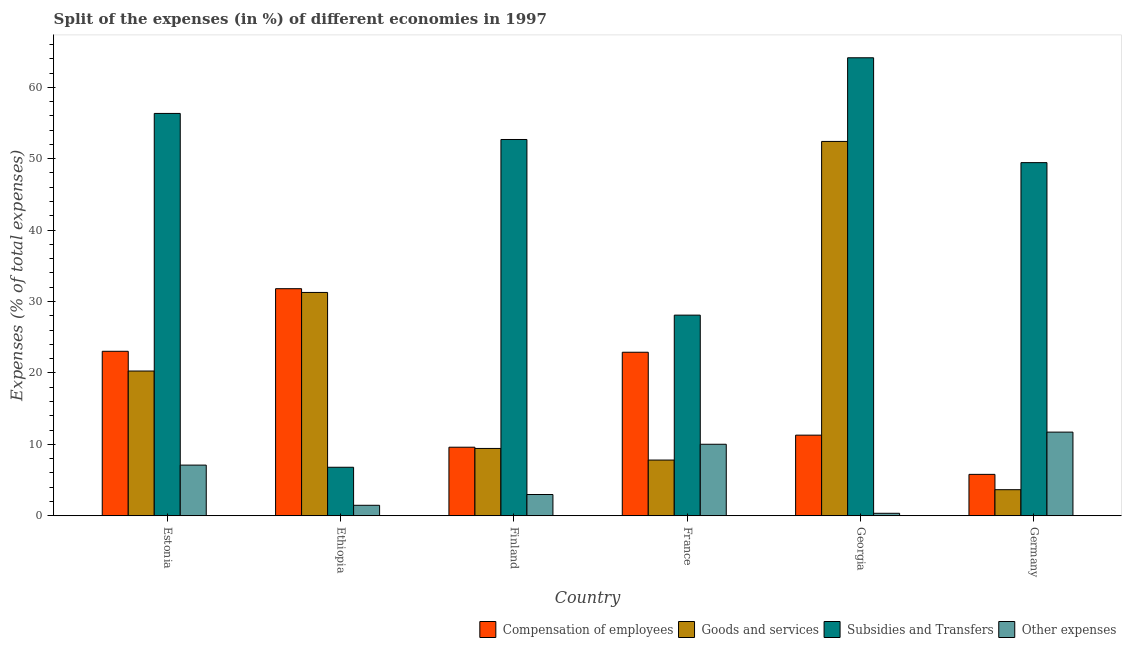How many different coloured bars are there?
Ensure brevity in your answer.  4. How many bars are there on the 2nd tick from the left?
Keep it short and to the point. 4. What is the label of the 5th group of bars from the left?
Your response must be concise. Georgia. In how many cases, is the number of bars for a given country not equal to the number of legend labels?
Ensure brevity in your answer.  0. What is the percentage of amount spent on goods and services in Germany?
Make the answer very short. 3.65. Across all countries, what is the maximum percentage of amount spent on compensation of employees?
Keep it short and to the point. 31.8. Across all countries, what is the minimum percentage of amount spent on compensation of employees?
Give a very brief answer. 5.8. In which country was the percentage of amount spent on other expenses minimum?
Your answer should be very brief. Georgia. What is the total percentage of amount spent on subsidies in the graph?
Your answer should be compact. 257.51. What is the difference between the percentage of amount spent on goods and services in Finland and that in Germany?
Give a very brief answer. 5.78. What is the difference between the percentage of amount spent on subsidies in Estonia and the percentage of amount spent on other expenses in Germany?
Provide a succinct answer. 44.62. What is the average percentage of amount spent on other expenses per country?
Offer a terse response. 5.61. What is the difference between the percentage of amount spent on subsidies and percentage of amount spent on goods and services in Georgia?
Provide a succinct answer. 11.71. What is the ratio of the percentage of amount spent on goods and services in Estonia to that in Germany?
Keep it short and to the point. 5.55. Is the difference between the percentage of amount spent on goods and services in France and Georgia greater than the difference between the percentage of amount spent on subsidies in France and Georgia?
Provide a short and direct response. No. What is the difference between the highest and the second highest percentage of amount spent on compensation of employees?
Provide a short and direct response. 8.76. What is the difference between the highest and the lowest percentage of amount spent on other expenses?
Give a very brief answer. 11.37. In how many countries, is the percentage of amount spent on other expenses greater than the average percentage of amount spent on other expenses taken over all countries?
Ensure brevity in your answer.  3. Is it the case that in every country, the sum of the percentage of amount spent on compensation of employees and percentage of amount spent on goods and services is greater than the sum of percentage of amount spent on other expenses and percentage of amount spent on subsidies?
Your answer should be very brief. No. What does the 1st bar from the left in Finland represents?
Provide a succinct answer. Compensation of employees. What does the 3rd bar from the right in Finland represents?
Keep it short and to the point. Goods and services. Is it the case that in every country, the sum of the percentage of amount spent on compensation of employees and percentage of amount spent on goods and services is greater than the percentage of amount spent on subsidies?
Make the answer very short. No. How many bars are there?
Provide a succinct answer. 24. What is the difference between two consecutive major ticks on the Y-axis?
Provide a succinct answer. 10. Are the values on the major ticks of Y-axis written in scientific E-notation?
Provide a short and direct response. No. Does the graph contain any zero values?
Your answer should be compact. No. Does the graph contain grids?
Make the answer very short. No. What is the title of the graph?
Your response must be concise. Split of the expenses (in %) of different economies in 1997. What is the label or title of the Y-axis?
Your answer should be very brief. Expenses (% of total expenses). What is the Expenses (% of total expenses) in Compensation of employees in Estonia?
Offer a terse response. 23.03. What is the Expenses (% of total expenses) of Goods and services in Estonia?
Ensure brevity in your answer.  20.27. What is the Expenses (% of total expenses) in Subsidies and Transfers in Estonia?
Your answer should be compact. 56.34. What is the Expenses (% of total expenses) of Other expenses in Estonia?
Your response must be concise. 7.1. What is the Expenses (% of total expenses) of Compensation of employees in Ethiopia?
Ensure brevity in your answer.  31.8. What is the Expenses (% of total expenses) of Goods and services in Ethiopia?
Offer a very short reply. 31.27. What is the Expenses (% of total expenses) in Subsidies and Transfers in Ethiopia?
Your response must be concise. 6.8. What is the Expenses (% of total expenses) in Other expenses in Ethiopia?
Your answer should be very brief. 1.47. What is the Expenses (% of total expenses) of Compensation of employees in Finland?
Your answer should be very brief. 9.6. What is the Expenses (% of total expenses) in Goods and services in Finland?
Your answer should be very brief. 9.43. What is the Expenses (% of total expenses) of Subsidies and Transfers in Finland?
Your answer should be compact. 52.69. What is the Expenses (% of total expenses) in Other expenses in Finland?
Offer a very short reply. 2.98. What is the Expenses (% of total expenses) in Compensation of employees in France?
Your answer should be compact. 22.9. What is the Expenses (% of total expenses) in Goods and services in France?
Your response must be concise. 7.81. What is the Expenses (% of total expenses) of Subsidies and Transfers in France?
Ensure brevity in your answer.  28.1. What is the Expenses (% of total expenses) in Other expenses in France?
Give a very brief answer. 10.02. What is the Expenses (% of total expenses) in Compensation of employees in Georgia?
Provide a succinct answer. 11.29. What is the Expenses (% of total expenses) in Goods and services in Georgia?
Your answer should be compact. 52.42. What is the Expenses (% of total expenses) of Subsidies and Transfers in Georgia?
Offer a terse response. 64.13. What is the Expenses (% of total expenses) of Other expenses in Georgia?
Make the answer very short. 0.35. What is the Expenses (% of total expenses) of Compensation of employees in Germany?
Provide a succinct answer. 5.8. What is the Expenses (% of total expenses) in Goods and services in Germany?
Give a very brief answer. 3.65. What is the Expenses (% of total expenses) of Subsidies and Transfers in Germany?
Your response must be concise. 49.45. What is the Expenses (% of total expenses) in Other expenses in Germany?
Your answer should be very brief. 11.72. Across all countries, what is the maximum Expenses (% of total expenses) in Compensation of employees?
Provide a short and direct response. 31.8. Across all countries, what is the maximum Expenses (% of total expenses) of Goods and services?
Give a very brief answer. 52.42. Across all countries, what is the maximum Expenses (% of total expenses) of Subsidies and Transfers?
Ensure brevity in your answer.  64.13. Across all countries, what is the maximum Expenses (% of total expenses) of Other expenses?
Offer a very short reply. 11.72. Across all countries, what is the minimum Expenses (% of total expenses) of Compensation of employees?
Your answer should be compact. 5.8. Across all countries, what is the minimum Expenses (% of total expenses) of Goods and services?
Provide a succinct answer. 3.65. Across all countries, what is the minimum Expenses (% of total expenses) in Subsidies and Transfers?
Make the answer very short. 6.8. Across all countries, what is the minimum Expenses (% of total expenses) in Other expenses?
Your answer should be compact. 0.35. What is the total Expenses (% of total expenses) of Compensation of employees in the graph?
Provide a succinct answer. 104.43. What is the total Expenses (% of total expenses) of Goods and services in the graph?
Keep it short and to the point. 124.86. What is the total Expenses (% of total expenses) in Subsidies and Transfers in the graph?
Your response must be concise. 257.51. What is the total Expenses (% of total expenses) of Other expenses in the graph?
Your answer should be very brief. 33.63. What is the difference between the Expenses (% of total expenses) in Compensation of employees in Estonia and that in Ethiopia?
Make the answer very short. -8.76. What is the difference between the Expenses (% of total expenses) in Goods and services in Estonia and that in Ethiopia?
Provide a short and direct response. -11. What is the difference between the Expenses (% of total expenses) of Subsidies and Transfers in Estonia and that in Ethiopia?
Keep it short and to the point. 49.54. What is the difference between the Expenses (% of total expenses) in Other expenses in Estonia and that in Ethiopia?
Your response must be concise. 5.63. What is the difference between the Expenses (% of total expenses) in Compensation of employees in Estonia and that in Finland?
Give a very brief answer. 13.43. What is the difference between the Expenses (% of total expenses) of Goods and services in Estonia and that in Finland?
Provide a succinct answer. 10.84. What is the difference between the Expenses (% of total expenses) in Subsidies and Transfers in Estonia and that in Finland?
Offer a very short reply. 3.65. What is the difference between the Expenses (% of total expenses) of Other expenses in Estonia and that in Finland?
Your response must be concise. 4.12. What is the difference between the Expenses (% of total expenses) of Compensation of employees in Estonia and that in France?
Your answer should be very brief. 0.13. What is the difference between the Expenses (% of total expenses) of Goods and services in Estonia and that in France?
Provide a short and direct response. 12.47. What is the difference between the Expenses (% of total expenses) in Subsidies and Transfers in Estonia and that in France?
Your answer should be very brief. 28.24. What is the difference between the Expenses (% of total expenses) of Other expenses in Estonia and that in France?
Give a very brief answer. -2.92. What is the difference between the Expenses (% of total expenses) of Compensation of employees in Estonia and that in Georgia?
Make the answer very short. 11.74. What is the difference between the Expenses (% of total expenses) of Goods and services in Estonia and that in Georgia?
Keep it short and to the point. -32.15. What is the difference between the Expenses (% of total expenses) in Subsidies and Transfers in Estonia and that in Georgia?
Offer a very short reply. -7.79. What is the difference between the Expenses (% of total expenses) of Other expenses in Estonia and that in Georgia?
Make the answer very short. 6.75. What is the difference between the Expenses (% of total expenses) in Compensation of employees in Estonia and that in Germany?
Offer a terse response. 17.23. What is the difference between the Expenses (% of total expenses) of Goods and services in Estonia and that in Germany?
Provide a succinct answer. 16.62. What is the difference between the Expenses (% of total expenses) in Subsidies and Transfers in Estonia and that in Germany?
Your response must be concise. 6.89. What is the difference between the Expenses (% of total expenses) of Other expenses in Estonia and that in Germany?
Offer a very short reply. -4.62. What is the difference between the Expenses (% of total expenses) of Compensation of employees in Ethiopia and that in Finland?
Your answer should be very brief. 22.2. What is the difference between the Expenses (% of total expenses) of Goods and services in Ethiopia and that in Finland?
Your response must be concise. 21.84. What is the difference between the Expenses (% of total expenses) of Subsidies and Transfers in Ethiopia and that in Finland?
Offer a terse response. -45.9. What is the difference between the Expenses (% of total expenses) in Other expenses in Ethiopia and that in Finland?
Provide a short and direct response. -1.51. What is the difference between the Expenses (% of total expenses) of Compensation of employees in Ethiopia and that in France?
Provide a short and direct response. 8.9. What is the difference between the Expenses (% of total expenses) of Goods and services in Ethiopia and that in France?
Your answer should be compact. 23.47. What is the difference between the Expenses (% of total expenses) in Subsidies and Transfers in Ethiopia and that in France?
Offer a very short reply. -21.3. What is the difference between the Expenses (% of total expenses) of Other expenses in Ethiopia and that in France?
Ensure brevity in your answer.  -8.54. What is the difference between the Expenses (% of total expenses) of Compensation of employees in Ethiopia and that in Georgia?
Keep it short and to the point. 20.51. What is the difference between the Expenses (% of total expenses) in Goods and services in Ethiopia and that in Georgia?
Ensure brevity in your answer.  -21.14. What is the difference between the Expenses (% of total expenses) of Subsidies and Transfers in Ethiopia and that in Georgia?
Give a very brief answer. -57.34. What is the difference between the Expenses (% of total expenses) in Other expenses in Ethiopia and that in Georgia?
Offer a terse response. 1.12. What is the difference between the Expenses (% of total expenses) in Compensation of employees in Ethiopia and that in Germany?
Your response must be concise. 26. What is the difference between the Expenses (% of total expenses) of Goods and services in Ethiopia and that in Germany?
Give a very brief answer. 27.62. What is the difference between the Expenses (% of total expenses) in Subsidies and Transfers in Ethiopia and that in Germany?
Your answer should be very brief. -42.66. What is the difference between the Expenses (% of total expenses) in Other expenses in Ethiopia and that in Germany?
Your answer should be very brief. -10.24. What is the difference between the Expenses (% of total expenses) in Compensation of employees in Finland and that in France?
Your answer should be compact. -13.3. What is the difference between the Expenses (% of total expenses) of Goods and services in Finland and that in France?
Give a very brief answer. 1.62. What is the difference between the Expenses (% of total expenses) of Subsidies and Transfers in Finland and that in France?
Ensure brevity in your answer.  24.59. What is the difference between the Expenses (% of total expenses) of Other expenses in Finland and that in France?
Offer a very short reply. -7.04. What is the difference between the Expenses (% of total expenses) in Compensation of employees in Finland and that in Georgia?
Your answer should be very brief. -1.69. What is the difference between the Expenses (% of total expenses) in Goods and services in Finland and that in Georgia?
Offer a terse response. -42.99. What is the difference between the Expenses (% of total expenses) of Subsidies and Transfers in Finland and that in Georgia?
Keep it short and to the point. -11.44. What is the difference between the Expenses (% of total expenses) of Other expenses in Finland and that in Georgia?
Make the answer very short. 2.63. What is the difference between the Expenses (% of total expenses) of Compensation of employees in Finland and that in Germany?
Give a very brief answer. 3.8. What is the difference between the Expenses (% of total expenses) of Goods and services in Finland and that in Germany?
Your answer should be compact. 5.78. What is the difference between the Expenses (% of total expenses) of Subsidies and Transfers in Finland and that in Germany?
Make the answer very short. 3.24. What is the difference between the Expenses (% of total expenses) in Other expenses in Finland and that in Germany?
Your response must be concise. -8.74. What is the difference between the Expenses (% of total expenses) of Compensation of employees in France and that in Georgia?
Provide a succinct answer. 11.61. What is the difference between the Expenses (% of total expenses) in Goods and services in France and that in Georgia?
Make the answer very short. -44.61. What is the difference between the Expenses (% of total expenses) of Subsidies and Transfers in France and that in Georgia?
Your answer should be very brief. -36.04. What is the difference between the Expenses (% of total expenses) in Other expenses in France and that in Georgia?
Offer a terse response. 9.67. What is the difference between the Expenses (% of total expenses) in Compensation of employees in France and that in Germany?
Keep it short and to the point. 17.1. What is the difference between the Expenses (% of total expenses) of Goods and services in France and that in Germany?
Provide a succinct answer. 4.15. What is the difference between the Expenses (% of total expenses) in Subsidies and Transfers in France and that in Germany?
Provide a succinct answer. -21.35. What is the difference between the Expenses (% of total expenses) of Other expenses in France and that in Germany?
Make the answer very short. -1.7. What is the difference between the Expenses (% of total expenses) in Compensation of employees in Georgia and that in Germany?
Ensure brevity in your answer.  5.49. What is the difference between the Expenses (% of total expenses) of Goods and services in Georgia and that in Germany?
Your response must be concise. 48.77. What is the difference between the Expenses (% of total expenses) of Subsidies and Transfers in Georgia and that in Germany?
Provide a short and direct response. 14.68. What is the difference between the Expenses (% of total expenses) of Other expenses in Georgia and that in Germany?
Make the answer very short. -11.37. What is the difference between the Expenses (% of total expenses) in Compensation of employees in Estonia and the Expenses (% of total expenses) in Goods and services in Ethiopia?
Offer a terse response. -8.24. What is the difference between the Expenses (% of total expenses) of Compensation of employees in Estonia and the Expenses (% of total expenses) of Subsidies and Transfers in Ethiopia?
Your answer should be very brief. 16.24. What is the difference between the Expenses (% of total expenses) of Compensation of employees in Estonia and the Expenses (% of total expenses) of Other expenses in Ethiopia?
Offer a very short reply. 21.56. What is the difference between the Expenses (% of total expenses) of Goods and services in Estonia and the Expenses (% of total expenses) of Subsidies and Transfers in Ethiopia?
Your answer should be very brief. 13.48. What is the difference between the Expenses (% of total expenses) in Goods and services in Estonia and the Expenses (% of total expenses) in Other expenses in Ethiopia?
Keep it short and to the point. 18.8. What is the difference between the Expenses (% of total expenses) in Subsidies and Transfers in Estonia and the Expenses (% of total expenses) in Other expenses in Ethiopia?
Offer a very short reply. 54.87. What is the difference between the Expenses (% of total expenses) in Compensation of employees in Estonia and the Expenses (% of total expenses) in Goods and services in Finland?
Ensure brevity in your answer.  13.6. What is the difference between the Expenses (% of total expenses) in Compensation of employees in Estonia and the Expenses (% of total expenses) in Subsidies and Transfers in Finland?
Keep it short and to the point. -29.66. What is the difference between the Expenses (% of total expenses) of Compensation of employees in Estonia and the Expenses (% of total expenses) of Other expenses in Finland?
Give a very brief answer. 20.05. What is the difference between the Expenses (% of total expenses) in Goods and services in Estonia and the Expenses (% of total expenses) in Subsidies and Transfers in Finland?
Provide a succinct answer. -32.42. What is the difference between the Expenses (% of total expenses) of Goods and services in Estonia and the Expenses (% of total expenses) of Other expenses in Finland?
Offer a terse response. 17.29. What is the difference between the Expenses (% of total expenses) of Subsidies and Transfers in Estonia and the Expenses (% of total expenses) of Other expenses in Finland?
Offer a very short reply. 53.36. What is the difference between the Expenses (% of total expenses) in Compensation of employees in Estonia and the Expenses (% of total expenses) in Goods and services in France?
Give a very brief answer. 15.23. What is the difference between the Expenses (% of total expenses) in Compensation of employees in Estonia and the Expenses (% of total expenses) in Subsidies and Transfers in France?
Ensure brevity in your answer.  -5.06. What is the difference between the Expenses (% of total expenses) in Compensation of employees in Estonia and the Expenses (% of total expenses) in Other expenses in France?
Offer a terse response. 13.02. What is the difference between the Expenses (% of total expenses) in Goods and services in Estonia and the Expenses (% of total expenses) in Subsidies and Transfers in France?
Make the answer very short. -7.83. What is the difference between the Expenses (% of total expenses) of Goods and services in Estonia and the Expenses (% of total expenses) of Other expenses in France?
Your response must be concise. 10.26. What is the difference between the Expenses (% of total expenses) of Subsidies and Transfers in Estonia and the Expenses (% of total expenses) of Other expenses in France?
Provide a succinct answer. 46.32. What is the difference between the Expenses (% of total expenses) in Compensation of employees in Estonia and the Expenses (% of total expenses) in Goods and services in Georgia?
Offer a terse response. -29.38. What is the difference between the Expenses (% of total expenses) in Compensation of employees in Estonia and the Expenses (% of total expenses) in Subsidies and Transfers in Georgia?
Your answer should be compact. -41.1. What is the difference between the Expenses (% of total expenses) of Compensation of employees in Estonia and the Expenses (% of total expenses) of Other expenses in Georgia?
Your answer should be very brief. 22.68. What is the difference between the Expenses (% of total expenses) in Goods and services in Estonia and the Expenses (% of total expenses) in Subsidies and Transfers in Georgia?
Offer a very short reply. -43.86. What is the difference between the Expenses (% of total expenses) in Goods and services in Estonia and the Expenses (% of total expenses) in Other expenses in Georgia?
Ensure brevity in your answer.  19.92. What is the difference between the Expenses (% of total expenses) in Subsidies and Transfers in Estonia and the Expenses (% of total expenses) in Other expenses in Georgia?
Give a very brief answer. 55.99. What is the difference between the Expenses (% of total expenses) of Compensation of employees in Estonia and the Expenses (% of total expenses) of Goods and services in Germany?
Your answer should be very brief. 19.38. What is the difference between the Expenses (% of total expenses) of Compensation of employees in Estonia and the Expenses (% of total expenses) of Subsidies and Transfers in Germany?
Your answer should be compact. -26.42. What is the difference between the Expenses (% of total expenses) in Compensation of employees in Estonia and the Expenses (% of total expenses) in Other expenses in Germany?
Offer a very short reply. 11.32. What is the difference between the Expenses (% of total expenses) in Goods and services in Estonia and the Expenses (% of total expenses) in Subsidies and Transfers in Germany?
Give a very brief answer. -29.18. What is the difference between the Expenses (% of total expenses) of Goods and services in Estonia and the Expenses (% of total expenses) of Other expenses in Germany?
Your response must be concise. 8.56. What is the difference between the Expenses (% of total expenses) of Subsidies and Transfers in Estonia and the Expenses (% of total expenses) of Other expenses in Germany?
Give a very brief answer. 44.62. What is the difference between the Expenses (% of total expenses) in Compensation of employees in Ethiopia and the Expenses (% of total expenses) in Goods and services in Finland?
Ensure brevity in your answer.  22.37. What is the difference between the Expenses (% of total expenses) in Compensation of employees in Ethiopia and the Expenses (% of total expenses) in Subsidies and Transfers in Finland?
Provide a succinct answer. -20.89. What is the difference between the Expenses (% of total expenses) of Compensation of employees in Ethiopia and the Expenses (% of total expenses) of Other expenses in Finland?
Keep it short and to the point. 28.82. What is the difference between the Expenses (% of total expenses) of Goods and services in Ethiopia and the Expenses (% of total expenses) of Subsidies and Transfers in Finland?
Make the answer very short. -21.42. What is the difference between the Expenses (% of total expenses) of Goods and services in Ethiopia and the Expenses (% of total expenses) of Other expenses in Finland?
Make the answer very short. 28.29. What is the difference between the Expenses (% of total expenses) in Subsidies and Transfers in Ethiopia and the Expenses (% of total expenses) in Other expenses in Finland?
Your response must be concise. 3.82. What is the difference between the Expenses (% of total expenses) in Compensation of employees in Ethiopia and the Expenses (% of total expenses) in Goods and services in France?
Provide a succinct answer. 23.99. What is the difference between the Expenses (% of total expenses) in Compensation of employees in Ethiopia and the Expenses (% of total expenses) in Subsidies and Transfers in France?
Give a very brief answer. 3.7. What is the difference between the Expenses (% of total expenses) of Compensation of employees in Ethiopia and the Expenses (% of total expenses) of Other expenses in France?
Make the answer very short. 21.78. What is the difference between the Expenses (% of total expenses) of Goods and services in Ethiopia and the Expenses (% of total expenses) of Subsidies and Transfers in France?
Provide a succinct answer. 3.18. What is the difference between the Expenses (% of total expenses) of Goods and services in Ethiopia and the Expenses (% of total expenses) of Other expenses in France?
Your answer should be compact. 21.26. What is the difference between the Expenses (% of total expenses) in Subsidies and Transfers in Ethiopia and the Expenses (% of total expenses) in Other expenses in France?
Your response must be concise. -3.22. What is the difference between the Expenses (% of total expenses) of Compensation of employees in Ethiopia and the Expenses (% of total expenses) of Goods and services in Georgia?
Your response must be concise. -20.62. What is the difference between the Expenses (% of total expenses) in Compensation of employees in Ethiopia and the Expenses (% of total expenses) in Subsidies and Transfers in Georgia?
Your answer should be very brief. -32.33. What is the difference between the Expenses (% of total expenses) of Compensation of employees in Ethiopia and the Expenses (% of total expenses) of Other expenses in Georgia?
Your answer should be compact. 31.45. What is the difference between the Expenses (% of total expenses) of Goods and services in Ethiopia and the Expenses (% of total expenses) of Subsidies and Transfers in Georgia?
Provide a short and direct response. -32.86. What is the difference between the Expenses (% of total expenses) of Goods and services in Ethiopia and the Expenses (% of total expenses) of Other expenses in Georgia?
Provide a short and direct response. 30.92. What is the difference between the Expenses (% of total expenses) in Subsidies and Transfers in Ethiopia and the Expenses (% of total expenses) in Other expenses in Georgia?
Ensure brevity in your answer.  6.45. What is the difference between the Expenses (% of total expenses) of Compensation of employees in Ethiopia and the Expenses (% of total expenses) of Goods and services in Germany?
Give a very brief answer. 28.14. What is the difference between the Expenses (% of total expenses) of Compensation of employees in Ethiopia and the Expenses (% of total expenses) of Subsidies and Transfers in Germany?
Offer a terse response. -17.65. What is the difference between the Expenses (% of total expenses) of Compensation of employees in Ethiopia and the Expenses (% of total expenses) of Other expenses in Germany?
Ensure brevity in your answer.  20.08. What is the difference between the Expenses (% of total expenses) in Goods and services in Ethiopia and the Expenses (% of total expenses) in Subsidies and Transfers in Germany?
Provide a short and direct response. -18.18. What is the difference between the Expenses (% of total expenses) of Goods and services in Ethiopia and the Expenses (% of total expenses) of Other expenses in Germany?
Make the answer very short. 19.56. What is the difference between the Expenses (% of total expenses) of Subsidies and Transfers in Ethiopia and the Expenses (% of total expenses) of Other expenses in Germany?
Provide a succinct answer. -4.92. What is the difference between the Expenses (% of total expenses) of Compensation of employees in Finland and the Expenses (% of total expenses) of Goods and services in France?
Your answer should be compact. 1.8. What is the difference between the Expenses (% of total expenses) in Compensation of employees in Finland and the Expenses (% of total expenses) in Subsidies and Transfers in France?
Make the answer very short. -18.49. What is the difference between the Expenses (% of total expenses) in Compensation of employees in Finland and the Expenses (% of total expenses) in Other expenses in France?
Keep it short and to the point. -0.41. What is the difference between the Expenses (% of total expenses) in Goods and services in Finland and the Expenses (% of total expenses) in Subsidies and Transfers in France?
Make the answer very short. -18.67. What is the difference between the Expenses (% of total expenses) of Goods and services in Finland and the Expenses (% of total expenses) of Other expenses in France?
Offer a terse response. -0.59. What is the difference between the Expenses (% of total expenses) of Subsidies and Transfers in Finland and the Expenses (% of total expenses) of Other expenses in France?
Provide a succinct answer. 42.68. What is the difference between the Expenses (% of total expenses) of Compensation of employees in Finland and the Expenses (% of total expenses) of Goods and services in Georgia?
Provide a succinct answer. -42.82. What is the difference between the Expenses (% of total expenses) in Compensation of employees in Finland and the Expenses (% of total expenses) in Subsidies and Transfers in Georgia?
Provide a short and direct response. -54.53. What is the difference between the Expenses (% of total expenses) in Compensation of employees in Finland and the Expenses (% of total expenses) in Other expenses in Georgia?
Provide a succinct answer. 9.25. What is the difference between the Expenses (% of total expenses) of Goods and services in Finland and the Expenses (% of total expenses) of Subsidies and Transfers in Georgia?
Your answer should be very brief. -54.7. What is the difference between the Expenses (% of total expenses) in Goods and services in Finland and the Expenses (% of total expenses) in Other expenses in Georgia?
Provide a short and direct response. 9.08. What is the difference between the Expenses (% of total expenses) in Subsidies and Transfers in Finland and the Expenses (% of total expenses) in Other expenses in Georgia?
Your answer should be compact. 52.34. What is the difference between the Expenses (% of total expenses) of Compensation of employees in Finland and the Expenses (% of total expenses) of Goods and services in Germany?
Make the answer very short. 5.95. What is the difference between the Expenses (% of total expenses) of Compensation of employees in Finland and the Expenses (% of total expenses) of Subsidies and Transfers in Germany?
Your answer should be compact. -39.85. What is the difference between the Expenses (% of total expenses) of Compensation of employees in Finland and the Expenses (% of total expenses) of Other expenses in Germany?
Your answer should be compact. -2.11. What is the difference between the Expenses (% of total expenses) in Goods and services in Finland and the Expenses (% of total expenses) in Subsidies and Transfers in Germany?
Make the answer very short. -40.02. What is the difference between the Expenses (% of total expenses) of Goods and services in Finland and the Expenses (% of total expenses) of Other expenses in Germany?
Offer a very short reply. -2.29. What is the difference between the Expenses (% of total expenses) of Subsidies and Transfers in Finland and the Expenses (% of total expenses) of Other expenses in Germany?
Your answer should be compact. 40.98. What is the difference between the Expenses (% of total expenses) in Compensation of employees in France and the Expenses (% of total expenses) in Goods and services in Georgia?
Your answer should be very brief. -29.52. What is the difference between the Expenses (% of total expenses) of Compensation of employees in France and the Expenses (% of total expenses) of Subsidies and Transfers in Georgia?
Ensure brevity in your answer.  -41.23. What is the difference between the Expenses (% of total expenses) of Compensation of employees in France and the Expenses (% of total expenses) of Other expenses in Georgia?
Offer a very short reply. 22.55. What is the difference between the Expenses (% of total expenses) of Goods and services in France and the Expenses (% of total expenses) of Subsidies and Transfers in Georgia?
Your response must be concise. -56.33. What is the difference between the Expenses (% of total expenses) in Goods and services in France and the Expenses (% of total expenses) in Other expenses in Georgia?
Offer a very short reply. 7.46. What is the difference between the Expenses (% of total expenses) of Subsidies and Transfers in France and the Expenses (% of total expenses) of Other expenses in Georgia?
Offer a very short reply. 27.75. What is the difference between the Expenses (% of total expenses) in Compensation of employees in France and the Expenses (% of total expenses) in Goods and services in Germany?
Your answer should be compact. 19.25. What is the difference between the Expenses (% of total expenses) in Compensation of employees in France and the Expenses (% of total expenses) in Subsidies and Transfers in Germany?
Your answer should be compact. -26.55. What is the difference between the Expenses (% of total expenses) in Compensation of employees in France and the Expenses (% of total expenses) in Other expenses in Germany?
Make the answer very short. 11.19. What is the difference between the Expenses (% of total expenses) in Goods and services in France and the Expenses (% of total expenses) in Subsidies and Transfers in Germany?
Your answer should be compact. -41.65. What is the difference between the Expenses (% of total expenses) of Goods and services in France and the Expenses (% of total expenses) of Other expenses in Germany?
Make the answer very short. -3.91. What is the difference between the Expenses (% of total expenses) of Subsidies and Transfers in France and the Expenses (% of total expenses) of Other expenses in Germany?
Make the answer very short. 16.38. What is the difference between the Expenses (% of total expenses) in Compensation of employees in Georgia and the Expenses (% of total expenses) in Goods and services in Germany?
Keep it short and to the point. 7.64. What is the difference between the Expenses (% of total expenses) in Compensation of employees in Georgia and the Expenses (% of total expenses) in Subsidies and Transfers in Germany?
Offer a terse response. -38.16. What is the difference between the Expenses (% of total expenses) in Compensation of employees in Georgia and the Expenses (% of total expenses) in Other expenses in Germany?
Make the answer very short. -0.42. What is the difference between the Expenses (% of total expenses) in Goods and services in Georgia and the Expenses (% of total expenses) in Subsidies and Transfers in Germany?
Offer a terse response. 2.97. What is the difference between the Expenses (% of total expenses) in Goods and services in Georgia and the Expenses (% of total expenses) in Other expenses in Germany?
Your response must be concise. 40.7. What is the difference between the Expenses (% of total expenses) in Subsidies and Transfers in Georgia and the Expenses (% of total expenses) in Other expenses in Germany?
Make the answer very short. 52.42. What is the average Expenses (% of total expenses) of Compensation of employees per country?
Offer a terse response. 17.41. What is the average Expenses (% of total expenses) in Goods and services per country?
Your answer should be compact. 20.81. What is the average Expenses (% of total expenses) of Subsidies and Transfers per country?
Your answer should be compact. 42.92. What is the average Expenses (% of total expenses) in Other expenses per country?
Provide a short and direct response. 5.61. What is the difference between the Expenses (% of total expenses) of Compensation of employees and Expenses (% of total expenses) of Goods and services in Estonia?
Make the answer very short. 2.76. What is the difference between the Expenses (% of total expenses) in Compensation of employees and Expenses (% of total expenses) in Subsidies and Transfers in Estonia?
Keep it short and to the point. -33.31. What is the difference between the Expenses (% of total expenses) in Compensation of employees and Expenses (% of total expenses) in Other expenses in Estonia?
Provide a succinct answer. 15.94. What is the difference between the Expenses (% of total expenses) of Goods and services and Expenses (% of total expenses) of Subsidies and Transfers in Estonia?
Offer a very short reply. -36.07. What is the difference between the Expenses (% of total expenses) of Goods and services and Expenses (% of total expenses) of Other expenses in Estonia?
Give a very brief answer. 13.17. What is the difference between the Expenses (% of total expenses) in Subsidies and Transfers and Expenses (% of total expenses) in Other expenses in Estonia?
Your response must be concise. 49.24. What is the difference between the Expenses (% of total expenses) of Compensation of employees and Expenses (% of total expenses) of Goods and services in Ethiopia?
Ensure brevity in your answer.  0.52. What is the difference between the Expenses (% of total expenses) of Compensation of employees and Expenses (% of total expenses) of Subsidies and Transfers in Ethiopia?
Offer a terse response. 25. What is the difference between the Expenses (% of total expenses) of Compensation of employees and Expenses (% of total expenses) of Other expenses in Ethiopia?
Keep it short and to the point. 30.33. What is the difference between the Expenses (% of total expenses) in Goods and services and Expenses (% of total expenses) in Subsidies and Transfers in Ethiopia?
Make the answer very short. 24.48. What is the difference between the Expenses (% of total expenses) of Goods and services and Expenses (% of total expenses) of Other expenses in Ethiopia?
Your answer should be very brief. 29.8. What is the difference between the Expenses (% of total expenses) in Subsidies and Transfers and Expenses (% of total expenses) in Other expenses in Ethiopia?
Provide a short and direct response. 5.33. What is the difference between the Expenses (% of total expenses) of Compensation of employees and Expenses (% of total expenses) of Goods and services in Finland?
Provide a short and direct response. 0.17. What is the difference between the Expenses (% of total expenses) in Compensation of employees and Expenses (% of total expenses) in Subsidies and Transfers in Finland?
Provide a short and direct response. -43.09. What is the difference between the Expenses (% of total expenses) in Compensation of employees and Expenses (% of total expenses) in Other expenses in Finland?
Make the answer very short. 6.62. What is the difference between the Expenses (% of total expenses) of Goods and services and Expenses (% of total expenses) of Subsidies and Transfers in Finland?
Provide a short and direct response. -43.26. What is the difference between the Expenses (% of total expenses) in Goods and services and Expenses (% of total expenses) in Other expenses in Finland?
Give a very brief answer. 6.45. What is the difference between the Expenses (% of total expenses) of Subsidies and Transfers and Expenses (% of total expenses) of Other expenses in Finland?
Your response must be concise. 49.71. What is the difference between the Expenses (% of total expenses) in Compensation of employees and Expenses (% of total expenses) in Goods and services in France?
Your answer should be compact. 15.1. What is the difference between the Expenses (% of total expenses) in Compensation of employees and Expenses (% of total expenses) in Subsidies and Transfers in France?
Your answer should be very brief. -5.2. What is the difference between the Expenses (% of total expenses) in Compensation of employees and Expenses (% of total expenses) in Other expenses in France?
Your answer should be very brief. 12.89. What is the difference between the Expenses (% of total expenses) in Goods and services and Expenses (% of total expenses) in Subsidies and Transfers in France?
Keep it short and to the point. -20.29. What is the difference between the Expenses (% of total expenses) in Goods and services and Expenses (% of total expenses) in Other expenses in France?
Your answer should be compact. -2.21. What is the difference between the Expenses (% of total expenses) in Subsidies and Transfers and Expenses (% of total expenses) in Other expenses in France?
Keep it short and to the point. 18.08. What is the difference between the Expenses (% of total expenses) of Compensation of employees and Expenses (% of total expenses) of Goods and services in Georgia?
Give a very brief answer. -41.13. What is the difference between the Expenses (% of total expenses) in Compensation of employees and Expenses (% of total expenses) in Subsidies and Transfers in Georgia?
Provide a succinct answer. -52.84. What is the difference between the Expenses (% of total expenses) in Compensation of employees and Expenses (% of total expenses) in Other expenses in Georgia?
Offer a terse response. 10.94. What is the difference between the Expenses (% of total expenses) of Goods and services and Expenses (% of total expenses) of Subsidies and Transfers in Georgia?
Keep it short and to the point. -11.71. What is the difference between the Expenses (% of total expenses) of Goods and services and Expenses (% of total expenses) of Other expenses in Georgia?
Make the answer very short. 52.07. What is the difference between the Expenses (% of total expenses) in Subsidies and Transfers and Expenses (% of total expenses) in Other expenses in Georgia?
Ensure brevity in your answer.  63.78. What is the difference between the Expenses (% of total expenses) of Compensation of employees and Expenses (% of total expenses) of Goods and services in Germany?
Your answer should be compact. 2.15. What is the difference between the Expenses (% of total expenses) of Compensation of employees and Expenses (% of total expenses) of Subsidies and Transfers in Germany?
Offer a terse response. -43.65. What is the difference between the Expenses (% of total expenses) of Compensation of employees and Expenses (% of total expenses) of Other expenses in Germany?
Ensure brevity in your answer.  -5.91. What is the difference between the Expenses (% of total expenses) in Goods and services and Expenses (% of total expenses) in Subsidies and Transfers in Germany?
Ensure brevity in your answer.  -45.8. What is the difference between the Expenses (% of total expenses) of Goods and services and Expenses (% of total expenses) of Other expenses in Germany?
Ensure brevity in your answer.  -8.06. What is the difference between the Expenses (% of total expenses) in Subsidies and Transfers and Expenses (% of total expenses) in Other expenses in Germany?
Your answer should be compact. 37.74. What is the ratio of the Expenses (% of total expenses) in Compensation of employees in Estonia to that in Ethiopia?
Keep it short and to the point. 0.72. What is the ratio of the Expenses (% of total expenses) of Goods and services in Estonia to that in Ethiopia?
Offer a very short reply. 0.65. What is the ratio of the Expenses (% of total expenses) in Subsidies and Transfers in Estonia to that in Ethiopia?
Provide a short and direct response. 8.29. What is the ratio of the Expenses (% of total expenses) of Other expenses in Estonia to that in Ethiopia?
Your answer should be very brief. 4.83. What is the ratio of the Expenses (% of total expenses) of Compensation of employees in Estonia to that in Finland?
Ensure brevity in your answer.  2.4. What is the ratio of the Expenses (% of total expenses) of Goods and services in Estonia to that in Finland?
Your answer should be compact. 2.15. What is the ratio of the Expenses (% of total expenses) of Subsidies and Transfers in Estonia to that in Finland?
Make the answer very short. 1.07. What is the ratio of the Expenses (% of total expenses) of Other expenses in Estonia to that in Finland?
Provide a short and direct response. 2.38. What is the ratio of the Expenses (% of total expenses) of Goods and services in Estonia to that in France?
Keep it short and to the point. 2.6. What is the ratio of the Expenses (% of total expenses) in Subsidies and Transfers in Estonia to that in France?
Provide a succinct answer. 2.01. What is the ratio of the Expenses (% of total expenses) of Other expenses in Estonia to that in France?
Provide a succinct answer. 0.71. What is the ratio of the Expenses (% of total expenses) of Compensation of employees in Estonia to that in Georgia?
Provide a short and direct response. 2.04. What is the ratio of the Expenses (% of total expenses) of Goods and services in Estonia to that in Georgia?
Your answer should be very brief. 0.39. What is the ratio of the Expenses (% of total expenses) of Subsidies and Transfers in Estonia to that in Georgia?
Offer a terse response. 0.88. What is the ratio of the Expenses (% of total expenses) in Other expenses in Estonia to that in Georgia?
Ensure brevity in your answer.  20.27. What is the ratio of the Expenses (% of total expenses) of Compensation of employees in Estonia to that in Germany?
Give a very brief answer. 3.97. What is the ratio of the Expenses (% of total expenses) in Goods and services in Estonia to that in Germany?
Offer a terse response. 5.55. What is the ratio of the Expenses (% of total expenses) of Subsidies and Transfers in Estonia to that in Germany?
Your answer should be compact. 1.14. What is the ratio of the Expenses (% of total expenses) of Other expenses in Estonia to that in Germany?
Your answer should be compact. 0.61. What is the ratio of the Expenses (% of total expenses) in Compensation of employees in Ethiopia to that in Finland?
Your answer should be compact. 3.31. What is the ratio of the Expenses (% of total expenses) of Goods and services in Ethiopia to that in Finland?
Make the answer very short. 3.32. What is the ratio of the Expenses (% of total expenses) of Subsidies and Transfers in Ethiopia to that in Finland?
Offer a very short reply. 0.13. What is the ratio of the Expenses (% of total expenses) of Other expenses in Ethiopia to that in Finland?
Provide a short and direct response. 0.49. What is the ratio of the Expenses (% of total expenses) of Compensation of employees in Ethiopia to that in France?
Your answer should be compact. 1.39. What is the ratio of the Expenses (% of total expenses) of Goods and services in Ethiopia to that in France?
Make the answer very short. 4.01. What is the ratio of the Expenses (% of total expenses) in Subsidies and Transfers in Ethiopia to that in France?
Make the answer very short. 0.24. What is the ratio of the Expenses (% of total expenses) of Other expenses in Ethiopia to that in France?
Offer a terse response. 0.15. What is the ratio of the Expenses (% of total expenses) in Compensation of employees in Ethiopia to that in Georgia?
Offer a terse response. 2.82. What is the ratio of the Expenses (% of total expenses) in Goods and services in Ethiopia to that in Georgia?
Your response must be concise. 0.6. What is the ratio of the Expenses (% of total expenses) in Subsidies and Transfers in Ethiopia to that in Georgia?
Your answer should be compact. 0.11. What is the ratio of the Expenses (% of total expenses) of Other expenses in Ethiopia to that in Georgia?
Offer a terse response. 4.2. What is the ratio of the Expenses (% of total expenses) in Compensation of employees in Ethiopia to that in Germany?
Provide a short and direct response. 5.48. What is the ratio of the Expenses (% of total expenses) in Goods and services in Ethiopia to that in Germany?
Provide a succinct answer. 8.56. What is the ratio of the Expenses (% of total expenses) of Subsidies and Transfers in Ethiopia to that in Germany?
Your answer should be very brief. 0.14. What is the ratio of the Expenses (% of total expenses) in Other expenses in Ethiopia to that in Germany?
Your answer should be very brief. 0.13. What is the ratio of the Expenses (% of total expenses) of Compensation of employees in Finland to that in France?
Make the answer very short. 0.42. What is the ratio of the Expenses (% of total expenses) of Goods and services in Finland to that in France?
Your answer should be very brief. 1.21. What is the ratio of the Expenses (% of total expenses) in Subsidies and Transfers in Finland to that in France?
Provide a short and direct response. 1.88. What is the ratio of the Expenses (% of total expenses) of Other expenses in Finland to that in France?
Provide a short and direct response. 0.3. What is the ratio of the Expenses (% of total expenses) in Compensation of employees in Finland to that in Georgia?
Make the answer very short. 0.85. What is the ratio of the Expenses (% of total expenses) of Goods and services in Finland to that in Georgia?
Your answer should be compact. 0.18. What is the ratio of the Expenses (% of total expenses) of Subsidies and Transfers in Finland to that in Georgia?
Your response must be concise. 0.82. What is the ratio of the Expenses (% of total expenses) of Other expenses in Finland to that in Georgia?
Offer a terse response. 8.51. What is the ratio of the Expenses (% of total expenses) in Compensation of employees in Finland to that in Germany?
Provide a short and direct response. 1.66. What is the ratio of the Expenses (% of total expenses) of Goods and services in Finland to that in Germany?
Offer a very short reply. 2.58. What is the ratio of the Expenses (% of total expenses) of Subsidies and Transfers in Finland to that in Germany?
Offer a very short reply. 1.07. What is the ratio of the Expenses (% of total expenses) in Other expenses in Finland to that in Germany?
Keep it short and to the point. 0.25. What is the ratio of the Expenses (% of total expenses) of Compensation of employees in France to that in Georgia?
Your answer should be compact. 2.03. What is the ratio of the Expenses (% of total expenses) of Goods and services in France to that in Georgia?
Your answer should be very brief. 0.15. What is the ratio of the Expenses (% of total expenses) in Subsidies and Transfers in France to that in Georgia?
Make the answer very short. 0.44. What is the ratio of the Expenses (% of total expenses) of Other expenses in France to that in Georgia?
Make the answer very short. 28.6. What is the ratio of the Expenses (% of total expenses) of Compensation of employees in France to that in Germany?
Offer a terse response. 3.95. What is the ratio of the Expenses (% of total expenses) of Goods and services in France to that in Germany?
Provide a short and direct response. 2.14. What is the ratio of the Expenses (% of total expenses) in Subsidies and Transfers in France to that in Germany?
Provide a short and direct response. 0.57. What is the ratio of the Expenses (% of total expenses) in Other expenses in France to that in Germany?
Offer a terse response. 0.85. What is the ratio of the Expenses (% of total expenses) in Compensation of employees in Georgia to that in Germany?
Your response must be concise. 1.95. What is the ratio of the Expenses (% of total expenses) in Goods and services in Georgia to that in Germany?
Offer a very short reply. 14.34. What is the ratio of the Expenses (% of total expenses) in Subsidies and Transfers in Georgia to that in Germany?
Give a very brief answer. 1.3. What is the ratio of the Expenses (% of total expenses) of Other expenses in Georgia to that in Germany?
Your response must be concise. 0.03. What is the difference between the highest and the second highest Expenses (% of total expenses) in Compensation of employees?
Provide a succinct answer. 8.76. What is the difference between the highest and the second highest Expenses (% of total expenses) of Goods and services?
Your answer should be compact. 21.14. What is the difference between the highest and the second highest Expenses (% of total expenses) in Subsidies and Transfers?
Keep it short and to the point. 7.79. What is the difference between the highest and the second highest Expenses (% of total expenses) of Other expenses?
Keep it short and to the point. 1.7. What is the difference between the highest and the lowest Expenses (% of total expenses) of Compensation of employees?
Your answer should be very brief. 26. What is the difference between the highest and the lowest Expenses (% of total expenses) of Goods and services?
Offer a very short reply. 48.77. What is the difference between the highest and the lowest Expenses (% of total expenses) in Subsidies and Transfers?
Keep it short and to the point. 57.34. What is the difference between the highest and the lowest Expenses (% of total expenses) of Other expenses?
Provide a short and direct response. 11.37. 